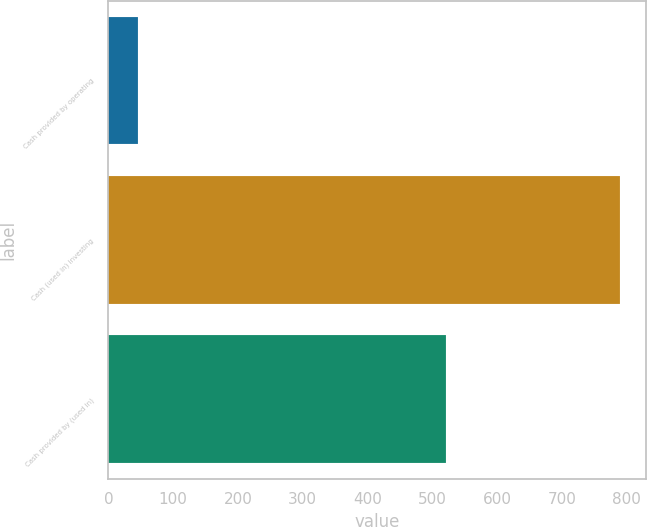Convert chart to OTSL. <chart><loc_0><loc_0><loc_500><loc_500><bar_chart><fcel>Cash provided by operating<fcel>Cash (used in) investing<fcel>Cash provided by (used in)<nl><fcel>45.8<fcel>790.3<fcel>521.1<nl></chart> 